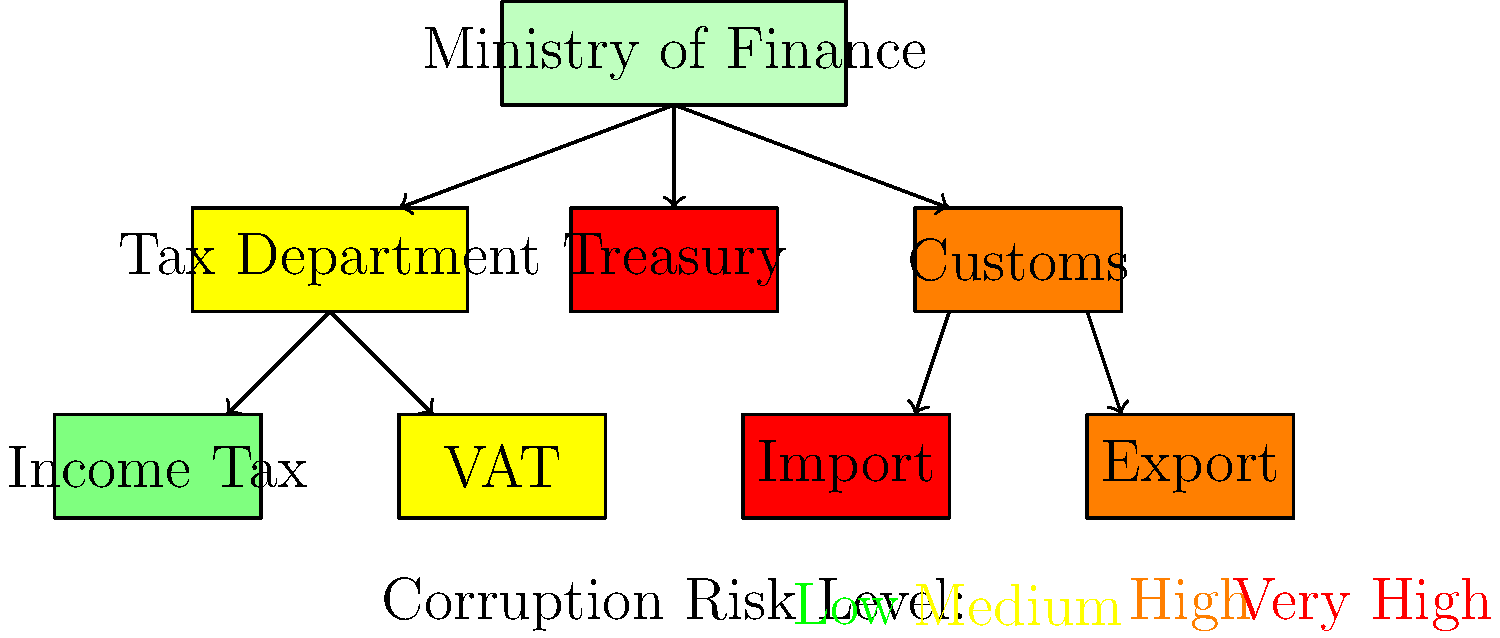Based on the hierarchical chart of the Ministry of Finance and its departments, which sub-department poses the highest corruption risk, and what immediate action should be taken to address this issue? To answer this question, we need to analyze the corruption risk levels indicated by the colors in the chart:

1. Identify the color coding:
   - Green: Low risk
   - Yellow: Medium risk
   - Orange: High risk
   - Red: Very high risk

2. Examine the departments and sub-departments:
   - Ministry of Finance (pale green): Low risk
   - Tax Department (yellow): Medium risk
     - Income Tax (light green): Low risk
     - VAT (yellow): Medium risk
   - Treasury (red): Very high risk
   - Customs (orange): High risk
     - Import (red): Very high risk
     - Export (orange): High risk

3. Identify the highest risk areas:
   - The Treasury and the Import sub-department of Customs both show very high risk (red).

4. Consider the hierarchical structure:
   - The Import sub-department is lower in the hierarchy, indicating a more specific area of concern.

5. Determine immediate action:
   - For the highest-risk area (Import sub-department), an immediate and thorough audit should be conducted to identify specific vulnerabilities and implement strict anti-corruption measures.

Given the Vietnamese context, where customs corruption has been a significant issue, focusing on the Import sub-department is crucial for addressing corruption risks in the finance sector.
Answer: Import sub-department; conduct immediate thorough audit and implement strict anti-corruption measures. 